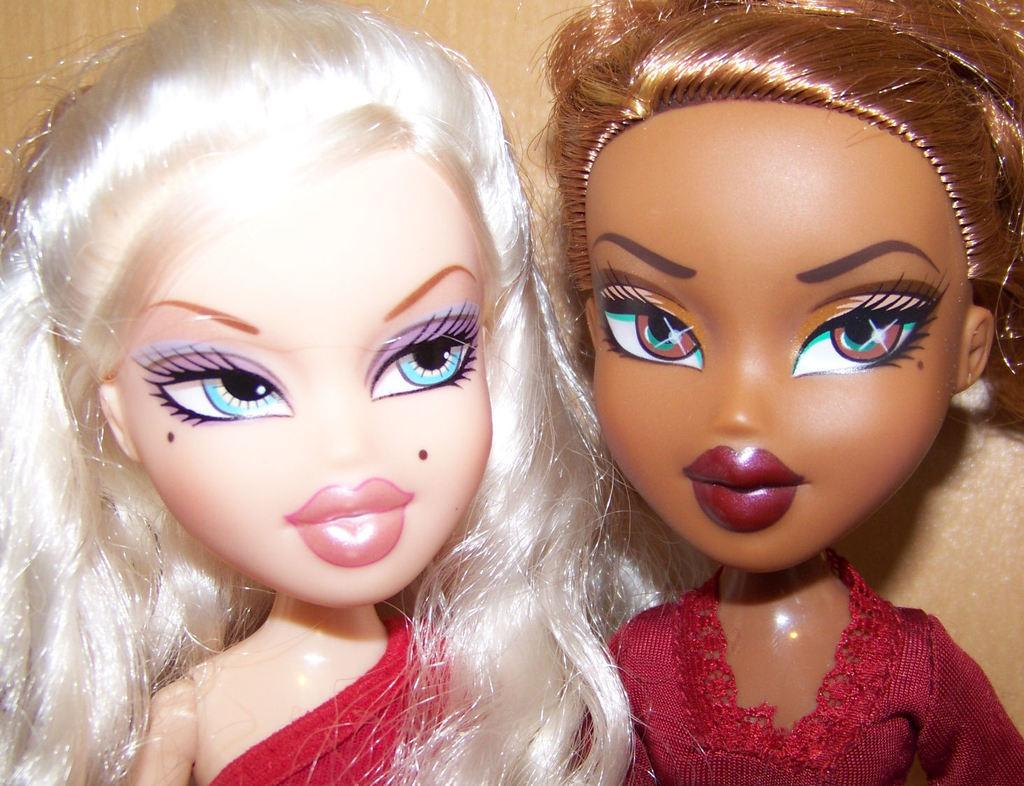How many dolls are present in the image? There are two dolls in the image. What type of scarf is the doll wearing in the image? There is no scarf present on the dolls in the image. What rhythm are the dolls dancing to in the image? The dolls are not dancing in the image, so there is no rhythm to be determined. 